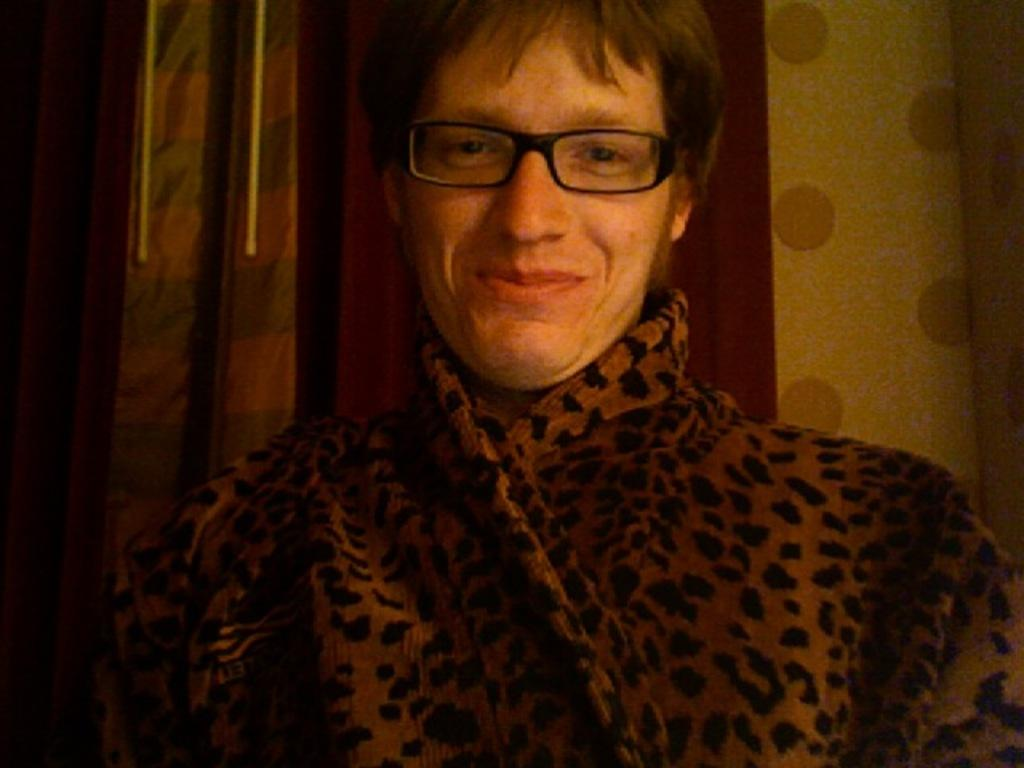What is the main subject in the foreground of the picture? There is a person in the foreground of the picture. What can be observed about the person's appearance? The person is wearing spectacles. Can you describe the background of the image? There might be curtains in the background of the image. What story is the writer telling in the prison depicted in the image? There is no story, writer, or prison present in the image; it features a person wearing spectacles in the foreground and possibly curtains in the background. 